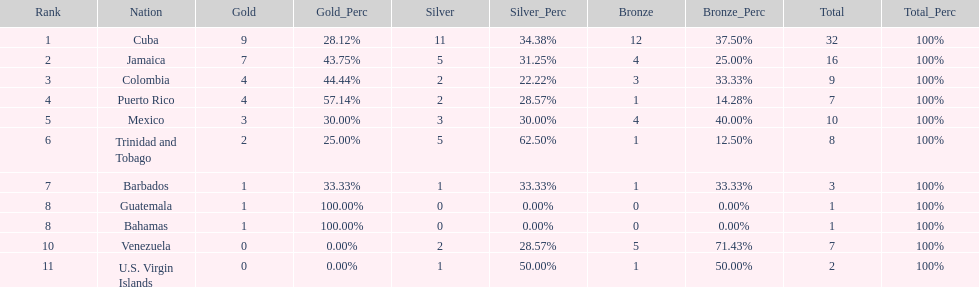Largest medal differential between countries 31. 